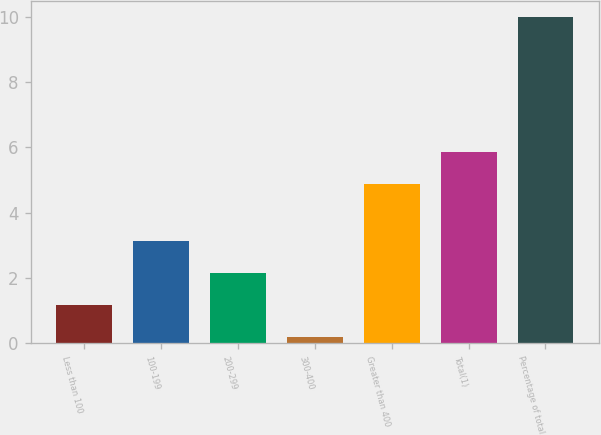Convert chart to OTSL. <chart><loc_0><loc_0><loc_500><loc_500><bar_chart><fcel>Less than 100<fcel>100-199<fcel>200-299<fcel>300-400<fcel>Greater than 400<fcel>Total(1)<fcel>Percentage of total<nl><fcel>1.18<fcel>3.14<fcel>2.16<fcel>0.2<fcel>4.89<fcel>5.87<fcel>10<nl></chart> 